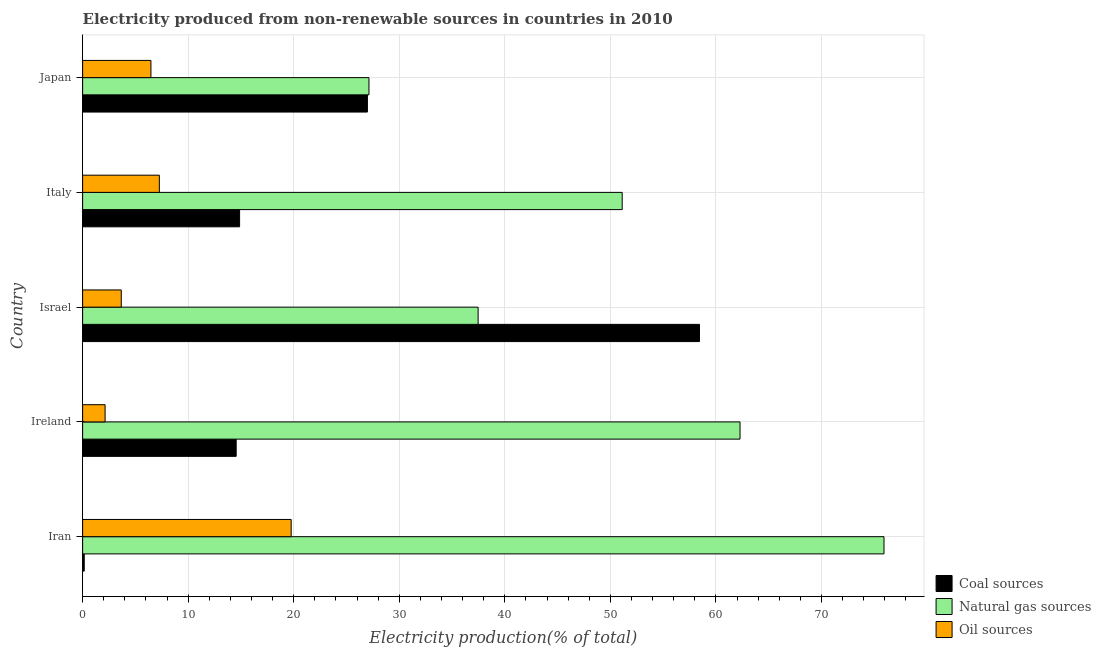How many different coloured bars are there?
Make the answer very short. 3. Are the number of bars per tick equal to the number of legend labels?
Your answer should be very brief. Yes. Are the number of bars on each tick of the Y-axis equal?
Your response must be concise. Yes. What is the label of the 5th group of bars from the top?
Offer a terse response. Iran. In how many cases, is the number of bars for a given country not equal to the number of legend labels?
Provide a short and direct response. 0. What is the percentage of electricity produced by natural gas in Iran?
Offer a terse response. 75.93. Across all countries, what is the maximum percentage of electricity produced by coal?
Offer a terse response. 58.44. Across all countries, what is the minimum percentage of electricity produced by oil sources?
Make the answer very short. 2.13. In which country was the percentage of electricity produced by coal maximum?
Provide a succinct answer. Israel. In which country was the percentage of electricity produced by natural gas minimum?
Provide a succinct answer. Japan. What is the total percentage of electricity produced by natural gas in the graph?
Keep it short and to the point. 253.93. What is the difference between the percentage of electricity produced by natural gas in Ireland and that in Italy?
Offer a terse response. 11.16. What is the difference between the percentage of electricity produced by coal in Japan and the percentage of electricity produced by natural gas in Italy?
Your answer should be very brief. -24.14. What is the average percentage of electricity produced by coal per country?
Your answer should be compact. 23. What is the difference between the percentage of electricity produced by coal and percentage of electricity produced by natural gas in Japan?
Keep it short and to the point. -0.15. What is the ratio of the percentage of electricity produced by coal in Iran to that in Israel?
Give a very brief answer. 0. Is the percentage of electricity produced by natural gas in Ireland less than that in Israel?
Offer a terse response. No. What is the difference between the highest and the second highest percentage of electricity produced by oil sources?
Offer a terse response. 12.49. What is the difference between the highest and the lowest percentage of electricity produced by coal?
Your answer should be compact. 58.29. What does the 1st bar from the top in Ireland represents?
Provide a short and direct response. Oil sources. What does the 3rd bar from the bottom in Japan represents?
Ensure brevity in your answer.  Oil sources. How many bars are there?
Provide a succinct answer. 15. How many countries are there in the graph?
Provide a short and direct response. 5. Are the values on the major ticks of X-axis written in scientific E-notation?
Keep it short and to the point. No. How many legend labels are there?
Provide a short and direct response. 3. What is the title of the graph?
Your response must be concise. Electricity produced from non-renewable sources in countries in 2010. Does "Ages 0-14" appear as one of the legend labels in the graph?
Give a very brief answer. No. What is the label or title of the X-axis?
Provide a short and direct response. Electricity production(% of total). What is the Electricity production(% of total) in Coal sources in Iran?
Offer a terse response. 0.15. What is the Electricity production(% of total) of Natural gas sources in Iran?
Your response must be concise. 75.93. What is the Electricity production(% of total) of Oil sources in Iran?
Provide a short and direct response. 19.76. What is the Electricity production(% of total) of Coal sources in Ireland?
Provide a succinct answer. 14.55. What is the Electricity production(% of total) in Natural gas sources in Ireland?
Your answer should be very brief. 62.29. What is the Electricity production(% of total) in Oil sources in Ireland?
Ensure brevity in your answer.  2.13. What is the Electricity production(% of total) in Coal sources in Israel?
Your response must be concise. 58.44. What is the Electricity production(% of total) of Natural gas sources in Israel?
Keep it short and to the point. 37.47. What is the Electricity production(% of total) of Oil sources in Israel?
Make the answer very short. 3.66. What is the Electricity production(% of total) of Coal sources in Italy?
Your answer should be very brief. 14.87. What is the Electricity production(% of total) in Natural gas sources in Italy?
Make the answer very short. 51.12. What is the Electricity production(% of total) of Oil sources in Italy?
Provide a succinct answer. 7.27. What is the Electricity production(% of total) of Coal sources in Japan?
Keep it short and to the point. 26.98. What is the Electricity production(% of total) of Natural gas sources in Japan?
Offer a very short reply. 27.13. What is the Electricity production(% of total) in Oil sources in Japan?
Ensure brevity in your answer.  6.47. Across all countries, what is the maximum Electricity production(% of total) in Coal sources?
Give a very brief answer. 58.44. Across all countries, what is the maximum Electricity production(% of total) of Natural gas sources?
Your answer should be very brief. 75.93. Across all countries, what is the maximum Electricity production(% of total) of Oil sources?
Offer a very short reply. 19.76. Across all countries, what is the minimum Electricity production(% of total) of Coal sources?
Offer a terse response. 0.15. Across all countries, what is the minimum Electricity production(% of total) in Natural gas sources?
Keep it short and to the point. 27.13. Across all countries, what is the minimum Electricity production(% of total) in Oil sources?
Provide a short and direct response. 2.13. What is the total Electricity production(% of total) in Coal sources in the graph?
Keep it short and to the point. 115. What is the total Electricity production(% of total) of Natural gas sources in the graph?
Offer a very short reply. 253.93. What is the total Electricity production(% of total) of Oil sources in the graph?
Ensure brevity in your answer.  39.29. What is the difference between the Electricity production(% of total) of Coal sources in Iran and that in Ireland?
Offer a terse response. -14.4. What is the difference between the Electricity production(% of total) in Natural gas sources in Iran and that in Ireland?
Provide a short and direct response. 13.64. What is the difference between the Electricity production(% of total) of Oil sources in Iran and that in Ireland?
Provide a short and direct response. 17.63. What is the difference between the Electricity production(% of total) of Coal sources in Iran and that in Israel?
Offer a very short reply. -58.29. What is the difference between the Electricity production(% of total) of Natural gas sources in Iran and that in Israel?
Your response must be concise. 38.45. What is the difference between the Electricity production(% of total) of Oil sources in Iran and that in Israel?
Provide a succinct answer. 16.1. What is the difference between the Electricity production(% of total) in Coal sources in Iran and that in Italy?
Your answer should be compact. -14.72. What is the difference between the Electricity production(% of total) of Natural gas sources in Iran and that in Italy?
Ensure brevity in your answer.  24.81. What is the difference between the Electricity production(% of total) of Oil sources in Iran and that in Italy?
Your response must be concise. 12.49. What is the difference between the Electricity production(% of total) in Coal sources in Iran and that in Japan?
Offer a terse response. -26.83. What is the difference between the Electricity production(% of total) in Natural gas sources in Iran and that in Japan?
Make the answer very short. 48.8. What is the difference between the Electricity production(% of total) in Oil sources in Iran and that in Japan?
Your answer should be very brief. 13.29. What is the difference between the Electricity production(% of total) in Coal sources in Ireland and that in Israel?
Keep it short and to the point. -43.9. What is the difference between the Electricity production(% of total) of Natural gas sources in Ireland and that in Israel?
Offer a very short reply. 24.82. What is the difference between the Electricity production(% of total) in Oil sources in Ireland and that in Israel?
Keep it short and to the point. -1.53. What is the difference between the Electricity production(% of total) in Coal sources in Ireland and that in Italy?
Offer a terse response. -0.33. What is the difference between the Electricity production(% of total) of Natural gas sources in Ireland and that in Italy?
Your response must be concise. 11.17. What is the difference between the Electricity production(% of total) in Oil sources in Ireland and that in Italy?
Your answer should be compact. -5.14. What is the difference between the Electricity production(% of total) of Coal sources in Ireland and that in Japan?
Provide a short and direct response. -12.43. What is the difference between the Electricity production(% of total) of Natural gas sources in Ireland and that in Japan?
Your answer should be compact. 35.16. What is the difference between the Electricity production(% of total) of Oil sources in Ireland and that in Japan?
Provide a short and direct response. -4.34. What is the difference between the Electricity production(% of total) of Coal sources in Israel and that in Italy?
Keep it short and to the point. 43.57. What is the difference between the Electricity production(% of total) in Natural gas sources in Israel and that in Italy?
Give a very brief answer. -13.65. What is the difference between the Electricity production(% of total) of Oil sources in Israel and that in Italy?
Provide a succinct answer. -3.61. What is the difference between the Electricity production(% of total) of Coal sources in Israel and that in Japan?
Offer a terse response. 31.46. What is the difference between the Electricity production(% of total) in Natural gas sources in Israel and that in Japan?
Your answer should be compact. 10.34. What is the difference between the Electricity production(% of total) of Oil sources in Israel and that in Japan?
Your response must be concise. -2.81. What is the difference between the Electricity production(% of total) of Coal sources in Italy and that in Japan?
Provide a short and direct response. -12.11. What is the difference between the Electricity production(% of total) of Natural gas sources in Italy and that in Japan?
Provide a short and direct response. 23.99. What is the difference between the Electricity production(% of total) of Oil sources in Italy and that in Japan?
Your answer should be compact. 0.8. What is the difference between the Electricity production(% of total) in Coal sources in Iran and the Electricity production(% of total) in Natural gas sources in Ireland?
Keep it short and to the point. -62.14. What is the difference between the Electricity production(% of total) in Coal sources in Iran and the Electricity production(% of total) in Oil sources in Ireland?
Provide a short and direct response. -1.98. What is the difference between the Electricity production(% of total) of Natural gas sources in Iran and the Electricity production(% of total) of Oil sources in Ireland?
Give a very brief answer. 73.8. What is the difference between the Electricity production(% of total) in Coal sources in Iran and the Electricity production(% of total) in Natural gas sources in Israel?
Your response must be concise. -37.32. What is the difference between the Electricity production(% of total) in Coal sources in Iran and the Electricity production(% of total) in Oil sources in Israel?
Offer a terse response. -3.51. What is the difference between the Electricity production(% of total) of Natural gas sources in Iran and the Electricity production(% of total) of Oil sources in Israel?
Keep it short and to the point. 72.27. What is the difference between the Electricity production(% of total) in Coal sources in Iran and the Electricity production(% of total) in Natural gas sources in Italy?
Ensure brevity in your answer.  -50.97. What is the difference between the Electricity production(% of total) of Coal sources in Iran and the Electricity production(% of total) of Oil sources in Italy?
Provide a succinct answer. -7.12. What is the difference between the Electricity production(% of total) of Natural gas sources in Iran and the Electricity production(% of total) of Oil sources in Italy?
Provide a succinct answer. 68.66. What is the difference between the Electricity production(% of total) in Coal sources in Iran and the Electricity production(% of total) in Natural gas sources in Japan?
Provide a short and direct response. -26.98. What is the difference between the Electricity production(% of total) of Coal sources in Iran and the Electricity production(% of total) of Oil sources in Japan?
Your answer should be very brief. -6.32. What is the difference between the Electricity production(% of total) of Natural gas sources in Iran and the Electricity production(% of total) of Oil sources in Japan?
Keep it short and to the point. 69.46. What is the difference between the Electricity production(% of total) in Coal sources in Ireland and the Electricity production(% of total) in Natural gas sources in Israel?
Offer a very short reply. -22.92. What is the difference between the Electricity production(% of total) of Coal sources in Ireland and the Electricity production(% of total) of Oil sources in Israel?
Offer a very short reply. 10.89. What is the difference between the Electricity production(% of total) in Natural gas sources in Ireland and the Electricity production(% of total) in Oil sources in Israel?
Provide a succinct answer. 58.63. What is the difference between the Electricity production(% of total) of Coal sources in Ireland and the Electricity production(% of total) of Natural gas sources in Italy?
Your response must be concise. -36.57. What is the difference between the Electricity production(% of total) in Coal sources in Ireland and the Electricity production(% of total) in Oil sources in Italy?
Your answer should be compact. 7.28. What is the difference between the Electricity production(% of total) of Natural gas sources in Ireland and the Electricity production(% of total) of Oil sources in Italy?
Ensure brevity in your answer.  55.02. What is the difference between the Electricity production(% of total) in Coal sources in Ireland and the Electricity production(% of total) in Natural gas sources in Japan?
Ensure brevity in your answer.  -12.58. What is the difference between the Electricity production(% of total) in Coal sources in Ireland and the Electricity production(% of total) in Oil sources in Japan?
Provide a short and direct response. 8.08. What is the difference between the Electricity production(% of total) of Natural gas sources in Ireland and the Electricity production(% of total) of Oil sources in Japan?
Your answer should be compact. 55.82. What is the difference between the Electricity production(% of total) of Coal sources in Israel and the Electricity production(% of total) of Natural gas sources in Italy?
Provide a succinct answer. 7.32. What is the difference between the Electricity production(% of total) of Coal sources in Israel and the Electricity production(% of total) of Oil sources in Italy?
Your answer should be compact. 51.18. What is the difference between the Electricity production(% of total) of Natural gas sources in Israel and the Electricity production(% of total) of Oil sources in Italy?
Keep it short and to the point. 30.2. What is the difference between the Electricity production(% of total) in Coal sources in Israel and the Electricity production(% of total) in Natural gas sources in Japan?
Give a very brief answer. 31.32. What is the difference between the Electricity production(% of total) of Coal sources in Israel and the Electricity production(% of total) of Oil sources in Japan?
Your response must be concise. 51.97. What is the difference between the Electricity production(% of total) of Natural gas sources in Israel and the Electricity production(% of total) of Oil sources in Japan?
Your answer should be very brief. 31. What is the difference between the Electricity production(% of total) in Coal sources in Italy and the Electricity production(% of total) in Natural gas sources in Japan?
Offer a very short reply. -12.26. What is the difference between the Electricity production(% of total) in Coal sources in Italy and the Electricity production(% of total) in Oil sources in Japan?
Ensure brevity in your answer.  8.4. What is the difference between the Electricity production(% of total) in Natural gas sources in Italy and the Electricity production(% of total) in Oil sources in Japan?
Provide a short and direct response. 44.65. What is the average Electricity production(% of total) of Coal sources per country?
Your response must be concise. 23. What is the average Electricity production(% of total) in Natural gas sources per country?
Your response must be concise. 50.79. What is the average Electricity production(% of total) of Oil sources per country?
Your response must be concise. 7.86. What is the difference between the Electricity production(% of total) of Coal sources and Electricity production(% of total) of Natural gas sources in Iran?
Offer a very short reply. -75.78. What is the difference between the Electricity production(% of total) of Coal sources and Electricity production(% of total) of Oil sources in Iran?
Offer a very short reply. -19.61. What is the difference between the Electricity production(% of total) of Natural gas sources and Electricity production(% of total) of Oil sources in Iran?
Keep it short and to the point. 56.17. What is the difference between the Electricity production(% of total) of Coal sources and Electricity production(% of total) of Natural gas sources in Ireland?
Give a very brief answer. -47.74. What is the difference between the Electricity production(% of total) of Coal sources and Electricity production(% of total) of Oil sources in Ireland?
Your response must be concise. 12.42. What is the difference between the Electricity production(% of total) in Natural gas sources and Electricity production(% of total) in Oil sources in Ireland?
Your answer should be very brief. 60.16. What is the difference between the Electricity production(% of total) of Coal sources and Electricity production(% of total) of Natural gas sources in Israel?
Provide a succinct answer. 20.97. What is the difference between the Electricity production(% of total) in Coal sources and Electricity production(% of total) in Oil sources in Israel?
Keep it short and to the point. 54.78. What is the difference between the Electricity production(% of total) of Natural gas sources and Electricity production(% of total) of Oil sources in Israel?
Keep it short and to the point. 33.81. What is the difference between the Electricity production(% of total) of Coal sources and Electricity production(% of total) of Natural gas sources in Italy?
Make the answer very short. -36.25. What is the difference between the Electricity production(% of total) in Coal sources and Electricity production(% of total) in Oil sources in Italy?
Ensure brevity in your answer.  7.6. What is the difference between the Electricity production(% of total) in Natural gas sources and Electricity production(% of total) in Oil sources in Italy?
Offer a very short reply. 43.85. What is the difference between the Electricity production(% of total) of Coal sources and Electricity production(% of total) of Natural gas sources in Japan?
Keep it short and to the point. -0.15. What is the difference between the Electricity production(% of total) in Coal sources and Electricity production(% of total) in Oil sources in Japan?
Give a very brief answer. 20.51. What is the difference between the Electricity production(% of total) of Natural gas sources and Electricity production(% of total) of Oil sources in Japan?
Your answer should be very brief. 20.66. What is the ratio of the Electricity production(% of total) in Coal sources in Iran to that in Ireland?
Provide a short and direct response. 0.01. What is the ratio of the Electricity production(% of total) of Natural gas sources in Iran to that in Ireland?
Provide a succinct answer. 1.22. What is the ratio of the Electricity production(% of total) of Oil sources in Iran to that in Ireland?
Make the answer very short. 9.28. What is the ratio of the Electricity production(% of total) in Coal sources in Iran to that in Israel?
Give a very brief answer. 0. What is the ratio of the Electricity production(% of total) in Natural gas sources in Iran to that in Israel?
Keep it short and to the point. 2.03. What is the ratio of the Electricity production(% of total) in Oil sources in Iran to that in Israel?
Your response must be concise. 5.4. What is the ratio of the Electricity production(% of total) in Coal sources in Iran to that in Italy?
Ensure brevity in your answer.  0.01. What is the ratio of the Electricity production(% of total) in Natural gas sources in Iran to that in Italy?
Your answer should be very brief. 1.49. What is the ratio of the Electricity production(% of total) in Oil sources in Iran to that in Italy?
Offer a terse response. 2.72. What is the ratio of the Electricity production(% of total) of Coal sources in Iran to that in Japan?
Make the answer very short. 0.01. What is the ratio of the Electricity production(% of total) in Natural gas sources in Iran to that in Japan?
Your answer should be compact. 2.8. What is the ratio of the Electricity production(% of total) in Oil sources in Iran to that in Japan?
Provide a short and direct response. 3.05. What is the ratio of the Electricity production(% of total) in Coal sources in Ireland to that in Israel?
Make the answer very short. 0.25. What is the ratio of the Electricity production(% of total) in Natural gas sources in Ireland to that in Israel?
Ensure brevity in your answer.  1.66. What is the ratio of the Electricity production(% of total) in Oil sources in Ireland to that in Israel?
Make the answer very short. 0.58. What is the ratio of the Electricity production(% of total) of Coal sources in Ireland to that in Italy?
Provide a succinct answer. 0.98. What is the ratio of the Electricity production(% of total) of Natural gas sources in Ireland to that in Italy?
Keep it short and to the point. 1.22. What is the ratio of the Electricity production(% of total) in Oil sources in Ireland to that in Italy?
Your answer should be very brief. 0.29. What is the ratio of the Electricity production(% of total) of Coal sources in Ireland to that in Japan?
Offer a terse response. 0.54. What is the ratio of the Electricity production(% of total) in Natural gas sources in Ireland to that in Japan?
Offer a very short reply. 2.3. What is the ratio of the Electricity production(% of total) of Oil sources in Ireland to that in Japan?
Give a very brief answer. 0.33. What is the ratio of the Electricity production(% of total) of Coal sources in Israel to that in Italy?
Ensure brevity in your answer.  3.93. What is the ratio of the Electricity production(% of total) of Natural gas sources in Israel to that in Italy?
Offer a terse response. 0.73. What is the ratio of the Electricity production(% of total) of Oil sources in Israel to that in Italy?
Provide a short and direct response. 0.5. What is the ratio of the Electricity production(% of total) of Coal sources in Israel to that in Japan?
Ensure brevity in your answer.  2.17. What is the ratio of the Electricity production(% of total) of Natural gas sources in Israel to that in Japan?
Ensure brevity in your answer.  1.38. What is the ratio of the Electricity production(% of total) in Oil sources in Israel to that in Japan?
Offer a terse response. 0.57. What is the ratio of the Electricity production(% of total) of Coal sources in Italy to that in Japan?
Your answer should be compact. 0.55. What is the ratio of the Electricity production(% of total) in Natural gas sources in Italy to that in Japan?
Provide a short and direct response. 1.88. What is the ratio of the Electricity production(% of total) in Oil sources in Italy to that in Japan?
Give a very brief answer. 1.12. What is the difference between the highest and the second highest Electricity production(% of total) of Coal sources?
Offer a very short reply. 31.46. What is the difference between the highest and the second highest Electricity production(% of total) of Natural gas sources?
Your response must be concise. 13.64. What is the difference between the highest and the second highest Electricity production(% of total) in Oil sources?
Offer a very short reply. 12.49. What is the difference between the highest and the lowest Electricity production(% of total) of Coal sources?
Make the answer very short. 58.29. What is the difference between the highest and the lowest Electricity production(% of total) in Natural gas sources?
Keep it short and to the point. 48.8. What is the difference between the highest and the lowest Electricity production(% of total) of Oil sources?
Offer a very short reply. 17.63. 